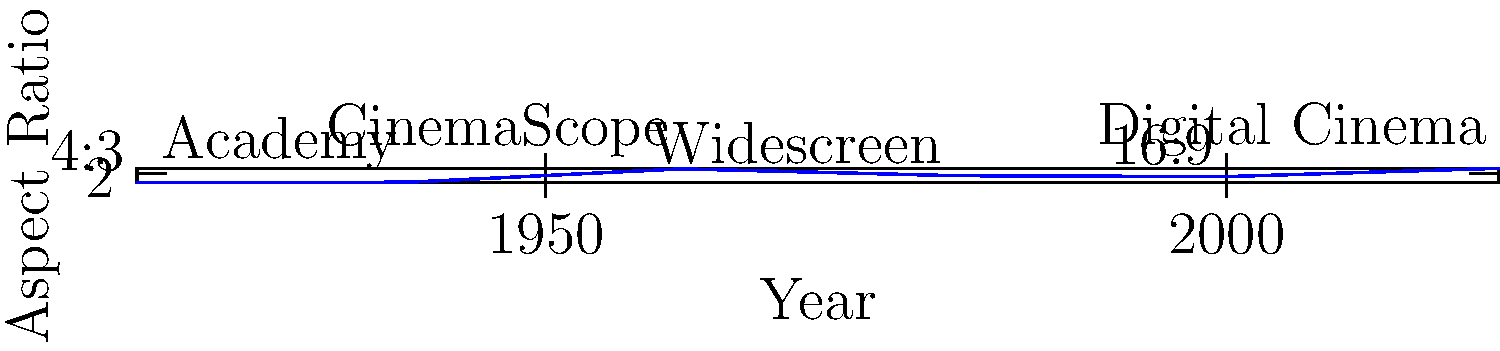Analyze the evolution of film aspect ratios from 1920 to 2020 as shown in the graph. Which aspect ratio became popular in the 1950s and 1960s, significantly widening the screen, and what technological advancement led to this change? To answer this question, let's analyze the graph step-by-step:

1. The graph shows the evolution of film aspect ratios from 1920 to 2020.

2. In 1920, we see the aspect ratio at about 1.33:1, which corresponds to the standard 4:3 ratio used in early films.

3. There's a slight increase to 1.37:1 around 1940, representing the Academy ratio.

4. A significant jump occurs between 1940 and 1960, where the aspect ratio increases to 2.35:1.

5. This wider aspect ratio is labeled "CinemaScope" on the graph, indicating it became popular in the 1950s and 1960s.

6. CinemaScope was a widescreen film process introduced by 20th Century Fox in 1953. It was developed to compete with television and bring audiences back to theaters.

7. The technological advancement that led to this change was the anamorphic lens system. This system allowed for a wider image to be squeezed onto standard 35mm film and then "unsqueezed" during projection, resulting in a much wider screen image.

8. After the 1960s, we see some fluctuation in aspect ratios, but none as dramatic as the shift to CinemaScope.

Therefore, the aspect ratio that became popular in the 1950s and 1960s, significantly widening the screen, was CinemaScope at 2.35:1. The technological advancement that led to this change was the anamorphic lens system.
Answer: CinemaScope (2.35:1), enabled by anamorphic lens technology. 